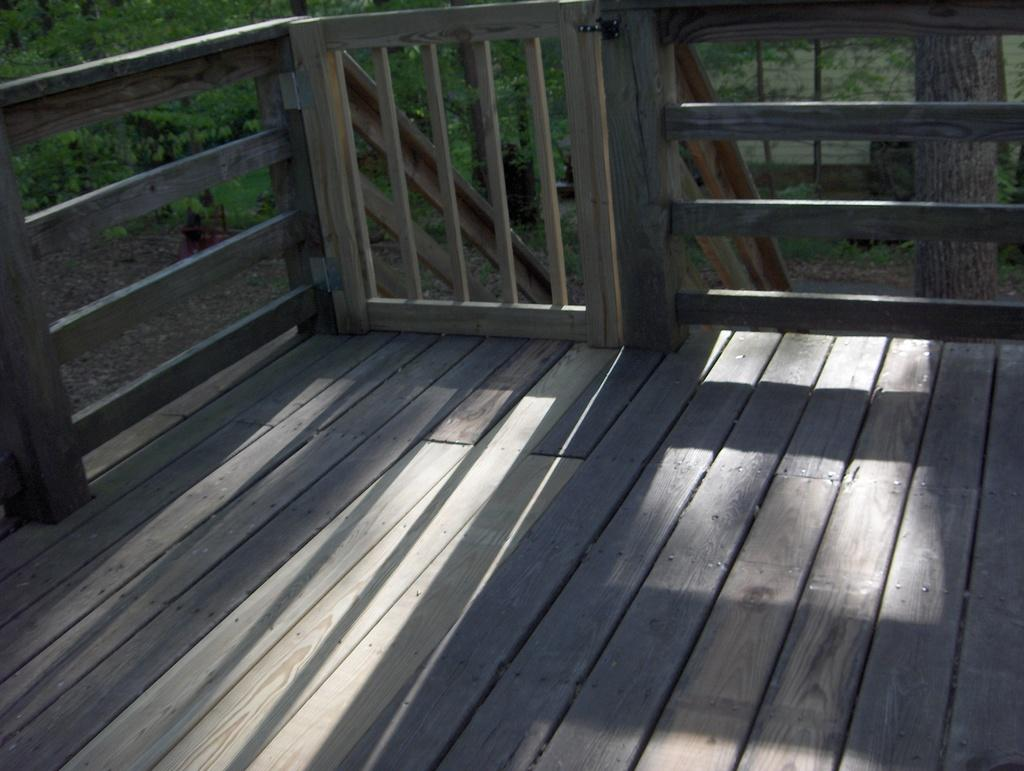What type of wooden structure can be seen in the image? There is a wooden object that resemblesembles a fence in the image. What other natural elements are present in the image? There are trees in the image. What other wooden objects can be seen in the image? There are wooden poles in the image. Is there any entrance or exit visible in the image? Yes, there is a door in the image. What is the laborer's income based on the image? There is no laborer or income information present in the image. What design elements can be seen in the image? The image does not focus on design elements; it primarily features wooden structures, trees, and a door. 